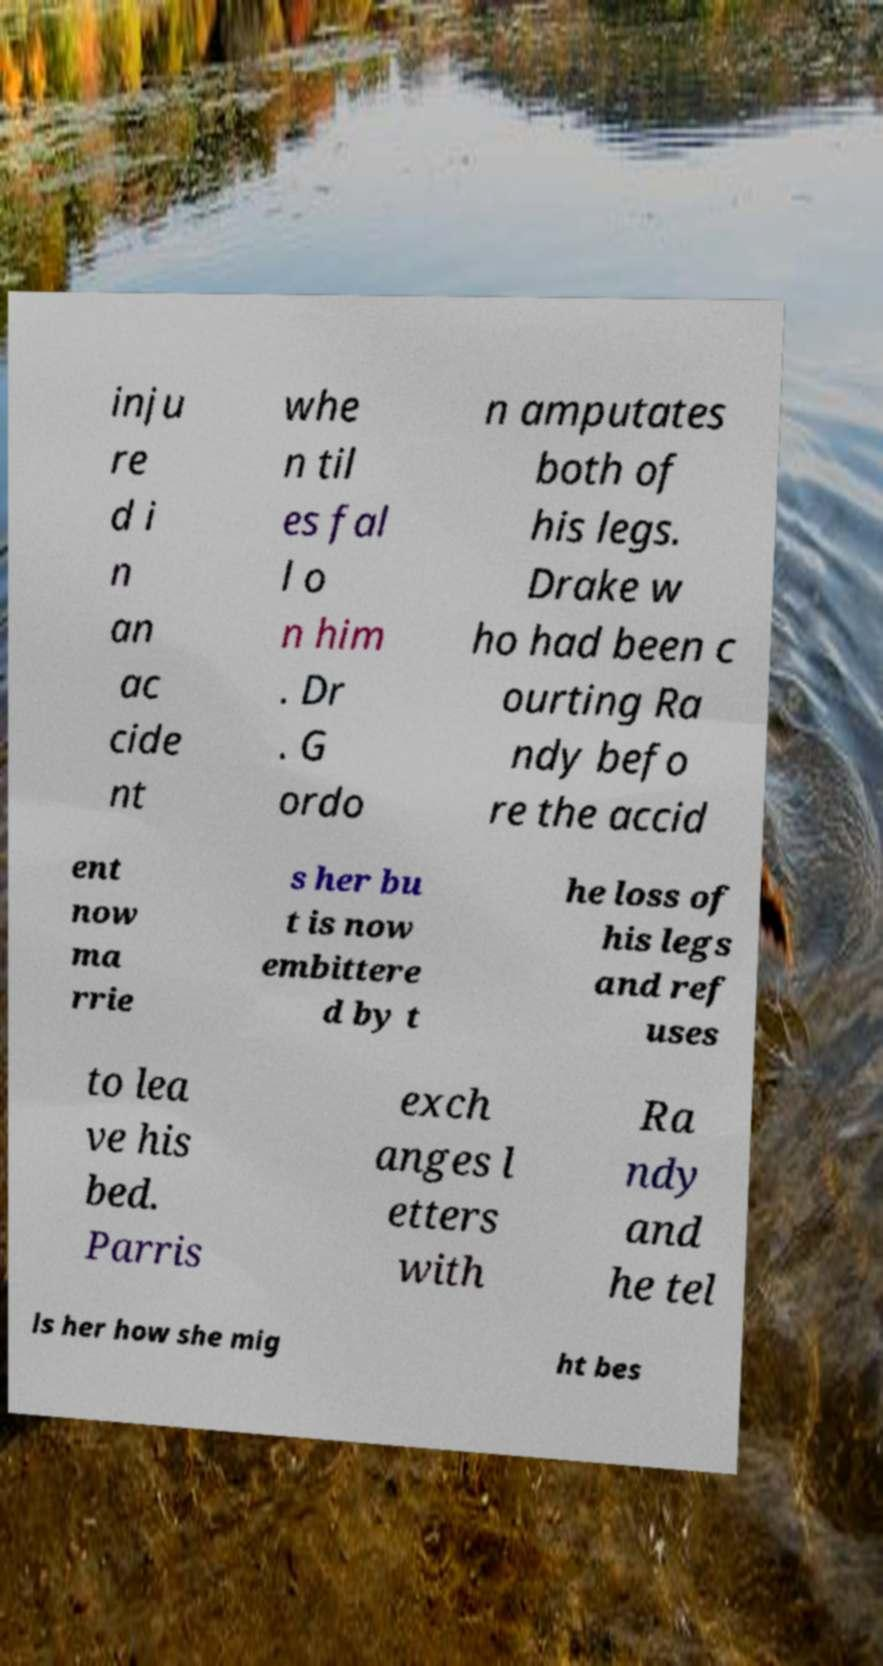Can you accurately transcribe the text from the provided image for me? inju re d i n an ac cide nt whe n til es fal l o n him . Dr . G ordo n amputates both of his legs. Drake w ho had been c ourting Ra ndy befo re the accid ent now ma rrie s her bu t is now embittere d by t he loss of his legs and ref uses to lea ve his bed. Parris exch anges l etters with Ra ndy and he tel ls her how she mig ht bes 